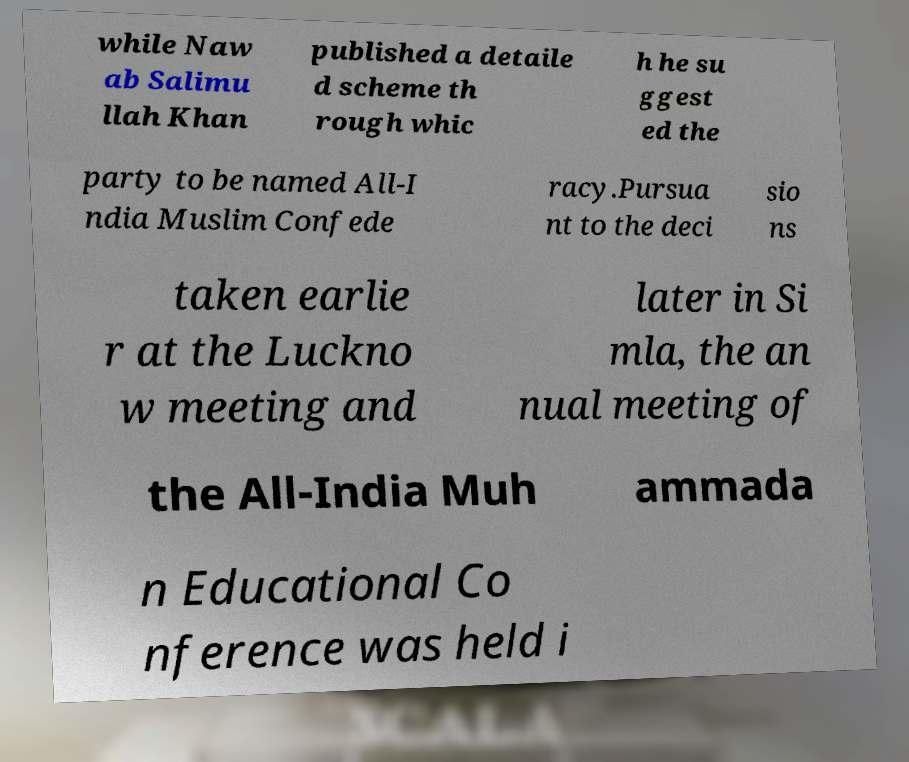Please identify and transcribe the text found in this image. while Naw ab Salimu llah Khan published a detaile d scheme th rough whic h he su ggest ed the party to be named All-I ndia Muslim Confede racy.Pursua nt to the deci sio ns taken earlie r at the Luckno w meeting and later in Si mla, the an nual meeting of the All-India Muh ammada n Educational Co nference was held i 